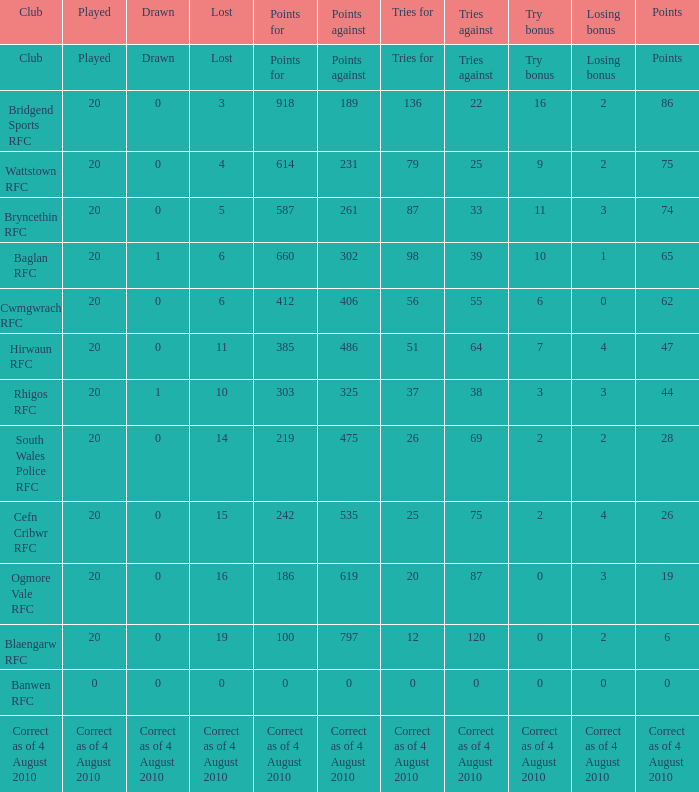What is the points when the club blaengarw rfc? 6.0. 